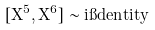<formula> <loc_0><loc_0><loc_500><loc_500>[ X ^ { 5 } , X ^ { 6 } ] \sim i \i d e n t i t y</formula> 